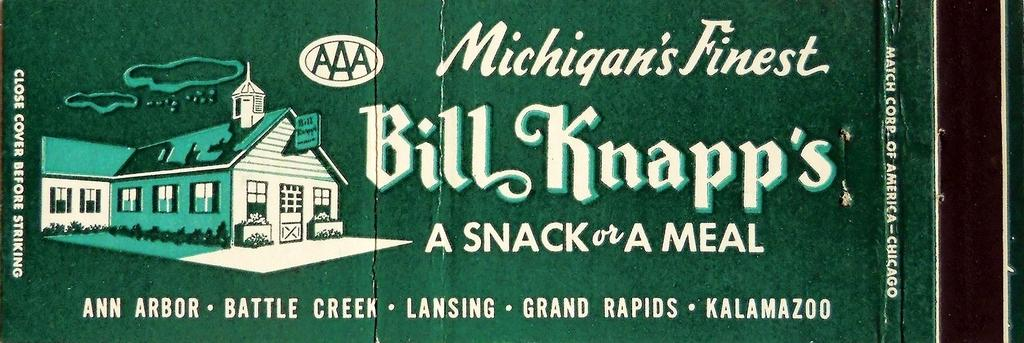What is the main subject of the image? The main subject of the image is a picture of a house. What else can be seen in the image besides the house? There are plants and texts written on a platform in the image. Can you see a toad hopping near the house in the image? There is no toad present in the image. Is there any indication of a battle taking place in the image? There is no indication of a battle in the image; it features a picture of a house, plants, and texts written on a platform. 